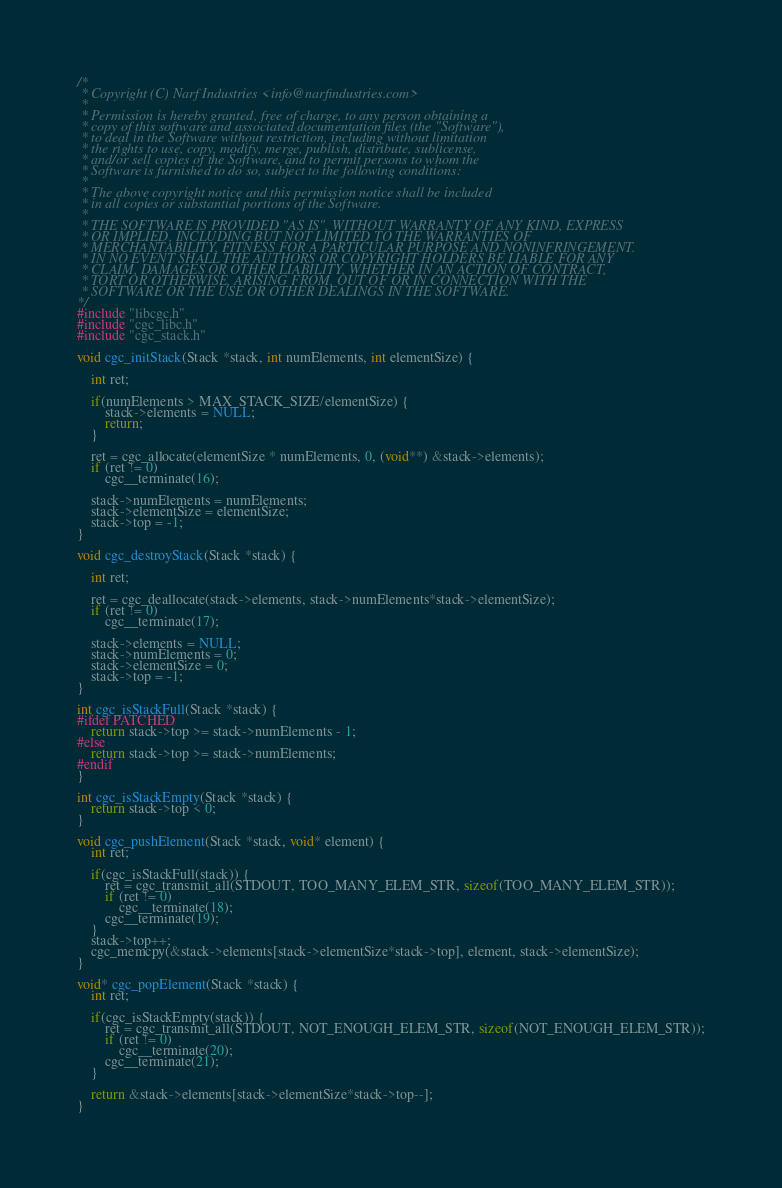Convert code to text. <code><loc_0><loc_0><loc_500><loc_500><_C_>/*
 * Copyright (C) Narf Industries <info@narfindustries.com>
 *
 * Permission is hereby granted, free of charge, to any person obtaining a
 * copy of this software and associated documentation files (the "Software"),
 * to deal in the Software without restriction, including without limitation
 * the rights to use, copy, modify, merge, publish, distribute, sublicense,
 * and/or sell copies of the Software, and to permit persons to whom the
 * Software is furnished to do so, subject to the following conditions:
 *
 * The above copyright notice and this permission notice shall be included
 * in all copies or substantial portions of the Software.
 *
 * THE SOFTWARE IS PROVIDED "AS IS", WITHOUT WARRANTY OF ANY KIND, EXPRESS
 * OR IMPLIED, INCLUDING BUT NOT LIMITED TO THE WARRANTIES OF
 * MERCHANTABILITY, FITNESS FOR A PARTICULAR PURPOSE AND NONINFRINGEMENT.
 * IN NO EVENT SHALL THE AUTHORS OR COPYRIGHT HOLDERS BE LIABLE FOR ANY
 * CLAIM, DAMAGES OR OTHER LIABILITY, WHETHER IN AN ACTION OF CONTRACT,
 * TORT OR OTHERWISE, ARISING FROM, OUT OF OR IN CONNECTION WITH THE
 * SOFTWARE OR THE USE OR OTHER DEALINGS IN THE SOFTWARE.
*/
#include "libcgc.h"
#include "cgc_libc.h"
#include "cgc_stack.h"

void cgc_initStack(Stack *stack, int numElements, int elementSize) {

	int ret;

	if(numElements > MAX_STACK_SIZE/elementSize) {
		stack->elements = NULL;
		return;
	}

	ret = cgc_allocate(elementSize * numElements, 0, (void**) &stack->elements);
	if (ret != 0)
		cgc__terminate(16);

	stack->numElements = numElements;
	stack->elementSize = elementSize;
	stack->top = -1;
}

void cgc_destroyStack(Stack *stack) {
	
	int ret;

	ret = cgc_deallocate(stack->elements, stack->numElements*stack->elementSize);
	if (ret != 0)
		cgc__terminate(17);

	stack->elements = NULL;
	stack->numElements = 0;
	stack->elementSize = 0;
	stack->top = -1;
}

int cgc_isStackFull(Stack *stack) {
#ifdef PATCHED
	return stack->top >= stack->numElements - 1;
#else
	return stack->top >= stack->numElements;
#endif
}

int cgc_isStackEmpty(Stack *stack) {
	return stack->top < 0;
}

void cgc_pushElement(Stack *stack, void* element) {
	int ret;

	if(cgc_isStackFull(stack)) {
		ret = cgc_transmit_all(STDOUT, TOO_MANY_ELEM_STR, sizeof(TOO_MANY_ELEM_STR));
    	if (ret != 0)
        	cgc__terminate(18);
        cgc__terminate(19);
	}
	stack->top++;
	cgc_memcpy(&stack->elements[stack->elementSize*stack->top], element, stack->elementSize);
}

void* cgc_popElement(Stack *stack) {
	int ret;

	if(cgc_isStackEmpty(stack)) {
		ret = cgc_transmit_all(STDOUT, NOT_ENOUGH_ELEM_STR, sizeof(NOT_ENOUGH_ELEM_STR));
    	if (ret != 0)
        	cgc__terminate(20);
        cgc__terminate(21);
	}

	return &stack->elements[stack->elementSize*stack->top--];
}
</code> 